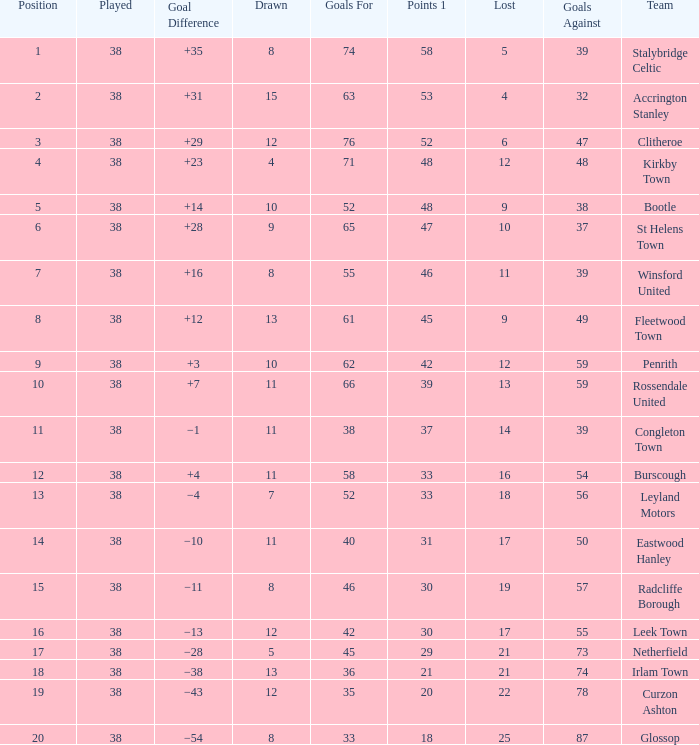What is the total number of losses for a draw of 7, and 1 points less than 33? 0.0. 